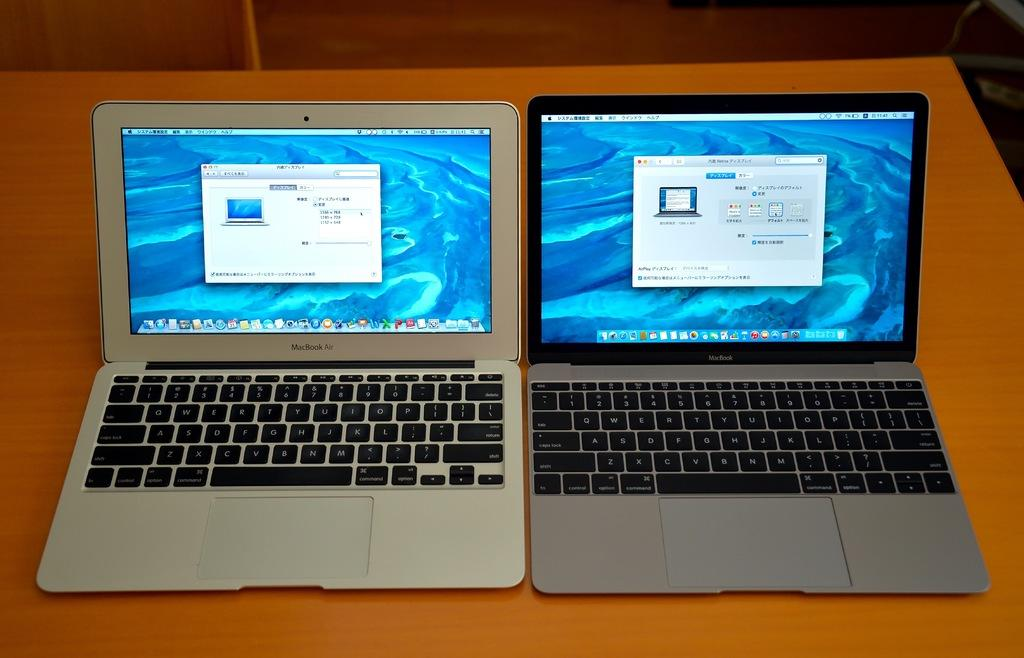<image>
Present a compact description of the photo's key features. A Macbook Air sits next to a Macbook, the time is shown as 11:41 on both. 